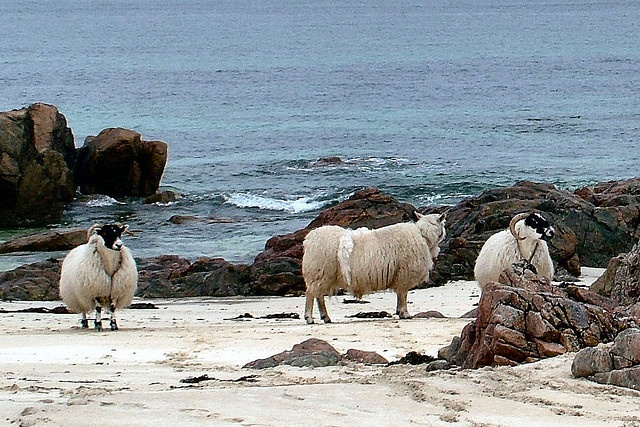Describe the objects in this image and their specific colors. I can see sheep in darkgray, lightgray, and gray tones, sheep in darkgray, lightgray, black, and gray tones, and sheep in darkgray, lightgray, black, and gray tones in this image. 